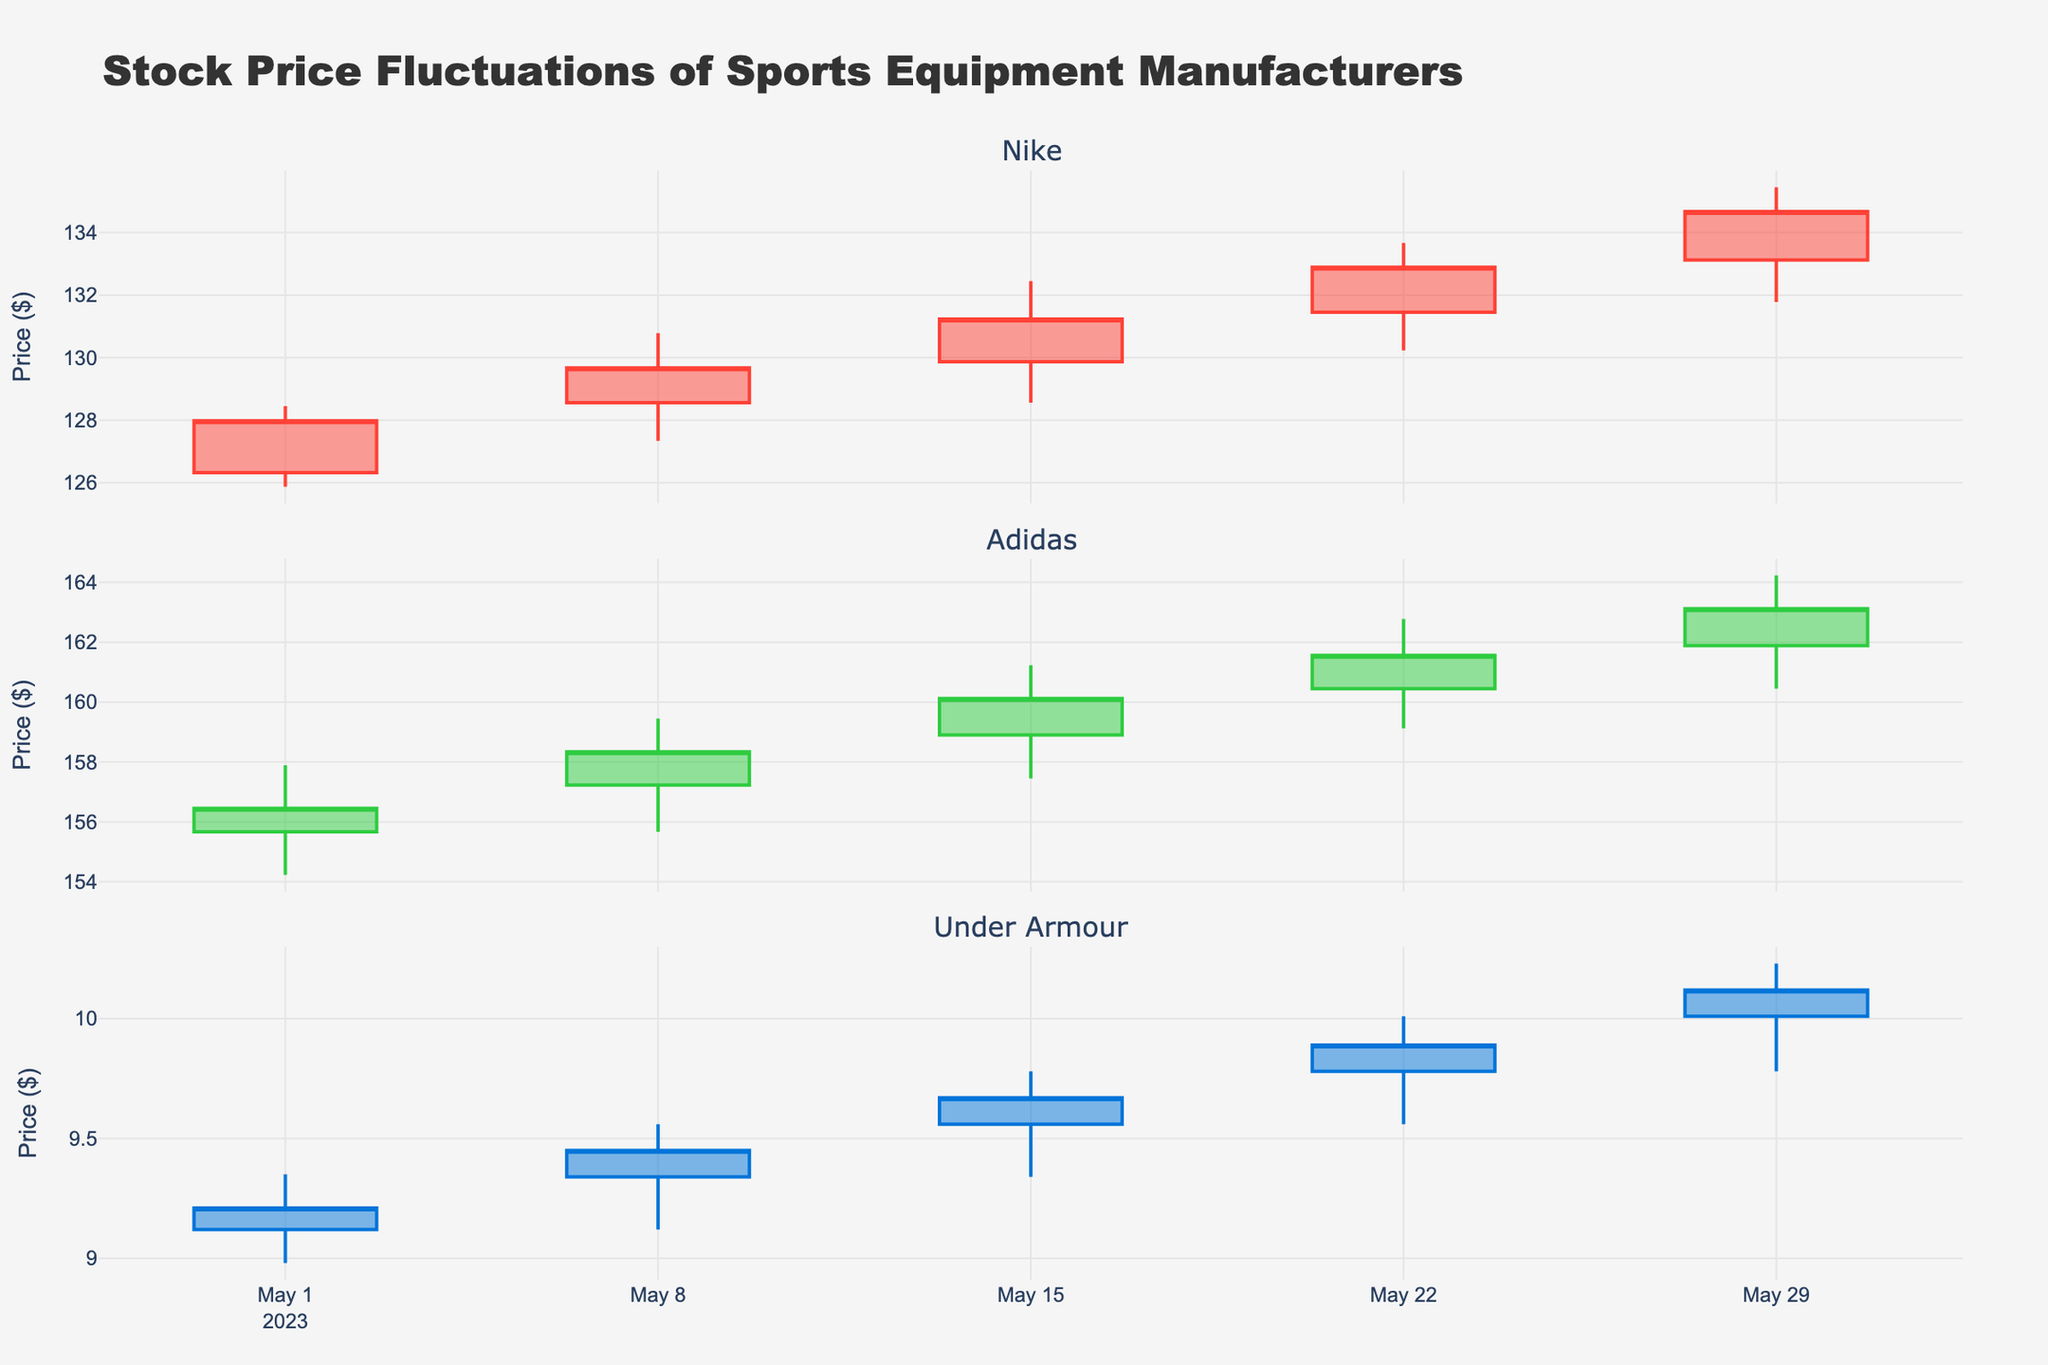What is the title of the plot? The title is located at the top of the plot, displayed prominently to summarize the chart's main subject. The plot's title is "Stock Price Fluctuations of Sports Equipment Manufacturers."
Answer: Stock Price Fluctuations of Sports Equipment Manufacturers Which company has the highest closing price on May 15, 2023? To find the highest closing price on May 15, 2023, look at the data points for each company on that date and compare their closing prices. Nike's closing price is 131.23, Adidas's closing price is 160.12, and Under Armour's closing price is 9.67. The highest closing price among these is Adidas with 160.12.
Answer: Adidas What is the overall trend of Nike's stock price over the month? To determine the overall trend for Nike, observe the progression of the closing prices throughout the month. Nike's closing prices are 127.98 to 129.67 to 131.23 to 132.89 to 134.67, indicating a steady upward trend over the month.
Answer: Upward trend On which date did Under Armour have the highest high price? To find the date when Under Armour had its highest high price, look for the highest value in the "High" column for Under Armour. The highest high price for Under Armour is 10.23, which occurred on May 29, 2023.
Answer: May 29, 2023 Compare the daily high prices of Adidas on May 1 and May 29. Which day had a higher high price? Compare the high prices of Adidas on the two given dates. On May 1, the high price is 157.89, and on May 29, the high price is 164.23. Therefore, the higher high price is on May 29.
Answer: May 29 What is the average closing price for Under Armour during the month? Calculate the average of Under Armour's closing prices across all dates: (9.21 + 9.45 + 9.67 + 9.89 + 10.12) / 5. The sum of the closing prices is 48.34, and dividing by 5 gives an average of 9.668.
Answer: 9.668 Describe the change in Adidas's closing price between May 8 and May 15. To find the change in closing prices, subtract the closing price on May 8 from the closing price on May 15. Adidas's closing prices are 158.34 on May 8 and 160.12 on May 15. Subtracting these values gives: 160.12 - 158.34 = 1.78.
Answer: Increased by 1.78 Which company showed the highest volatility on May 22? Volatility is often measured by the range between high and low prices. For May 22, calculate the range for each company: Nike (133.67 - 130.23 = 3.44), Adidas (162.78 - 159.12 = 3.66), and Under Armour (10.01 - 9.56 = 0.45). Adidas has the highest range, hence the highest volatility.
Answer: Adidas What is the median closing price for Adidas for the month? List Adidas's closing prices in ascending order: 156.45, 158.34, 160.12, 161.56, 163.12. The median is the middle value in this sorted list. For Adidas, the median closing price is the third number in the list, which is 160.12.
Answer: 160.12 Which company's stock price had the lowest close on May 1? Compare the closing prices of each company on May 1. Nike's closing price is 127.98, Adidas's closing price is 156.45, and Under Armour's closing price is 9.21. The lowest closing price among these is Under Armour's 9.21.
Answer: Under Armour 